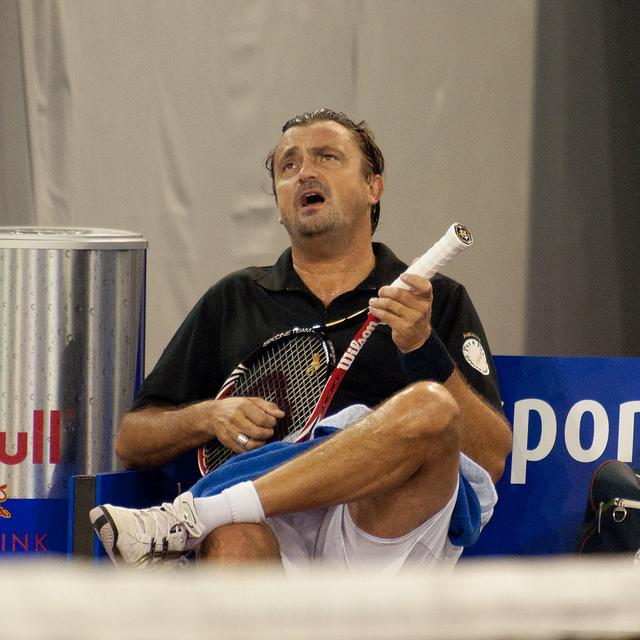He is pretending the tennis racket is what?

Choices:
A) guitar
B) violin
C) cello
D) flute guitar 